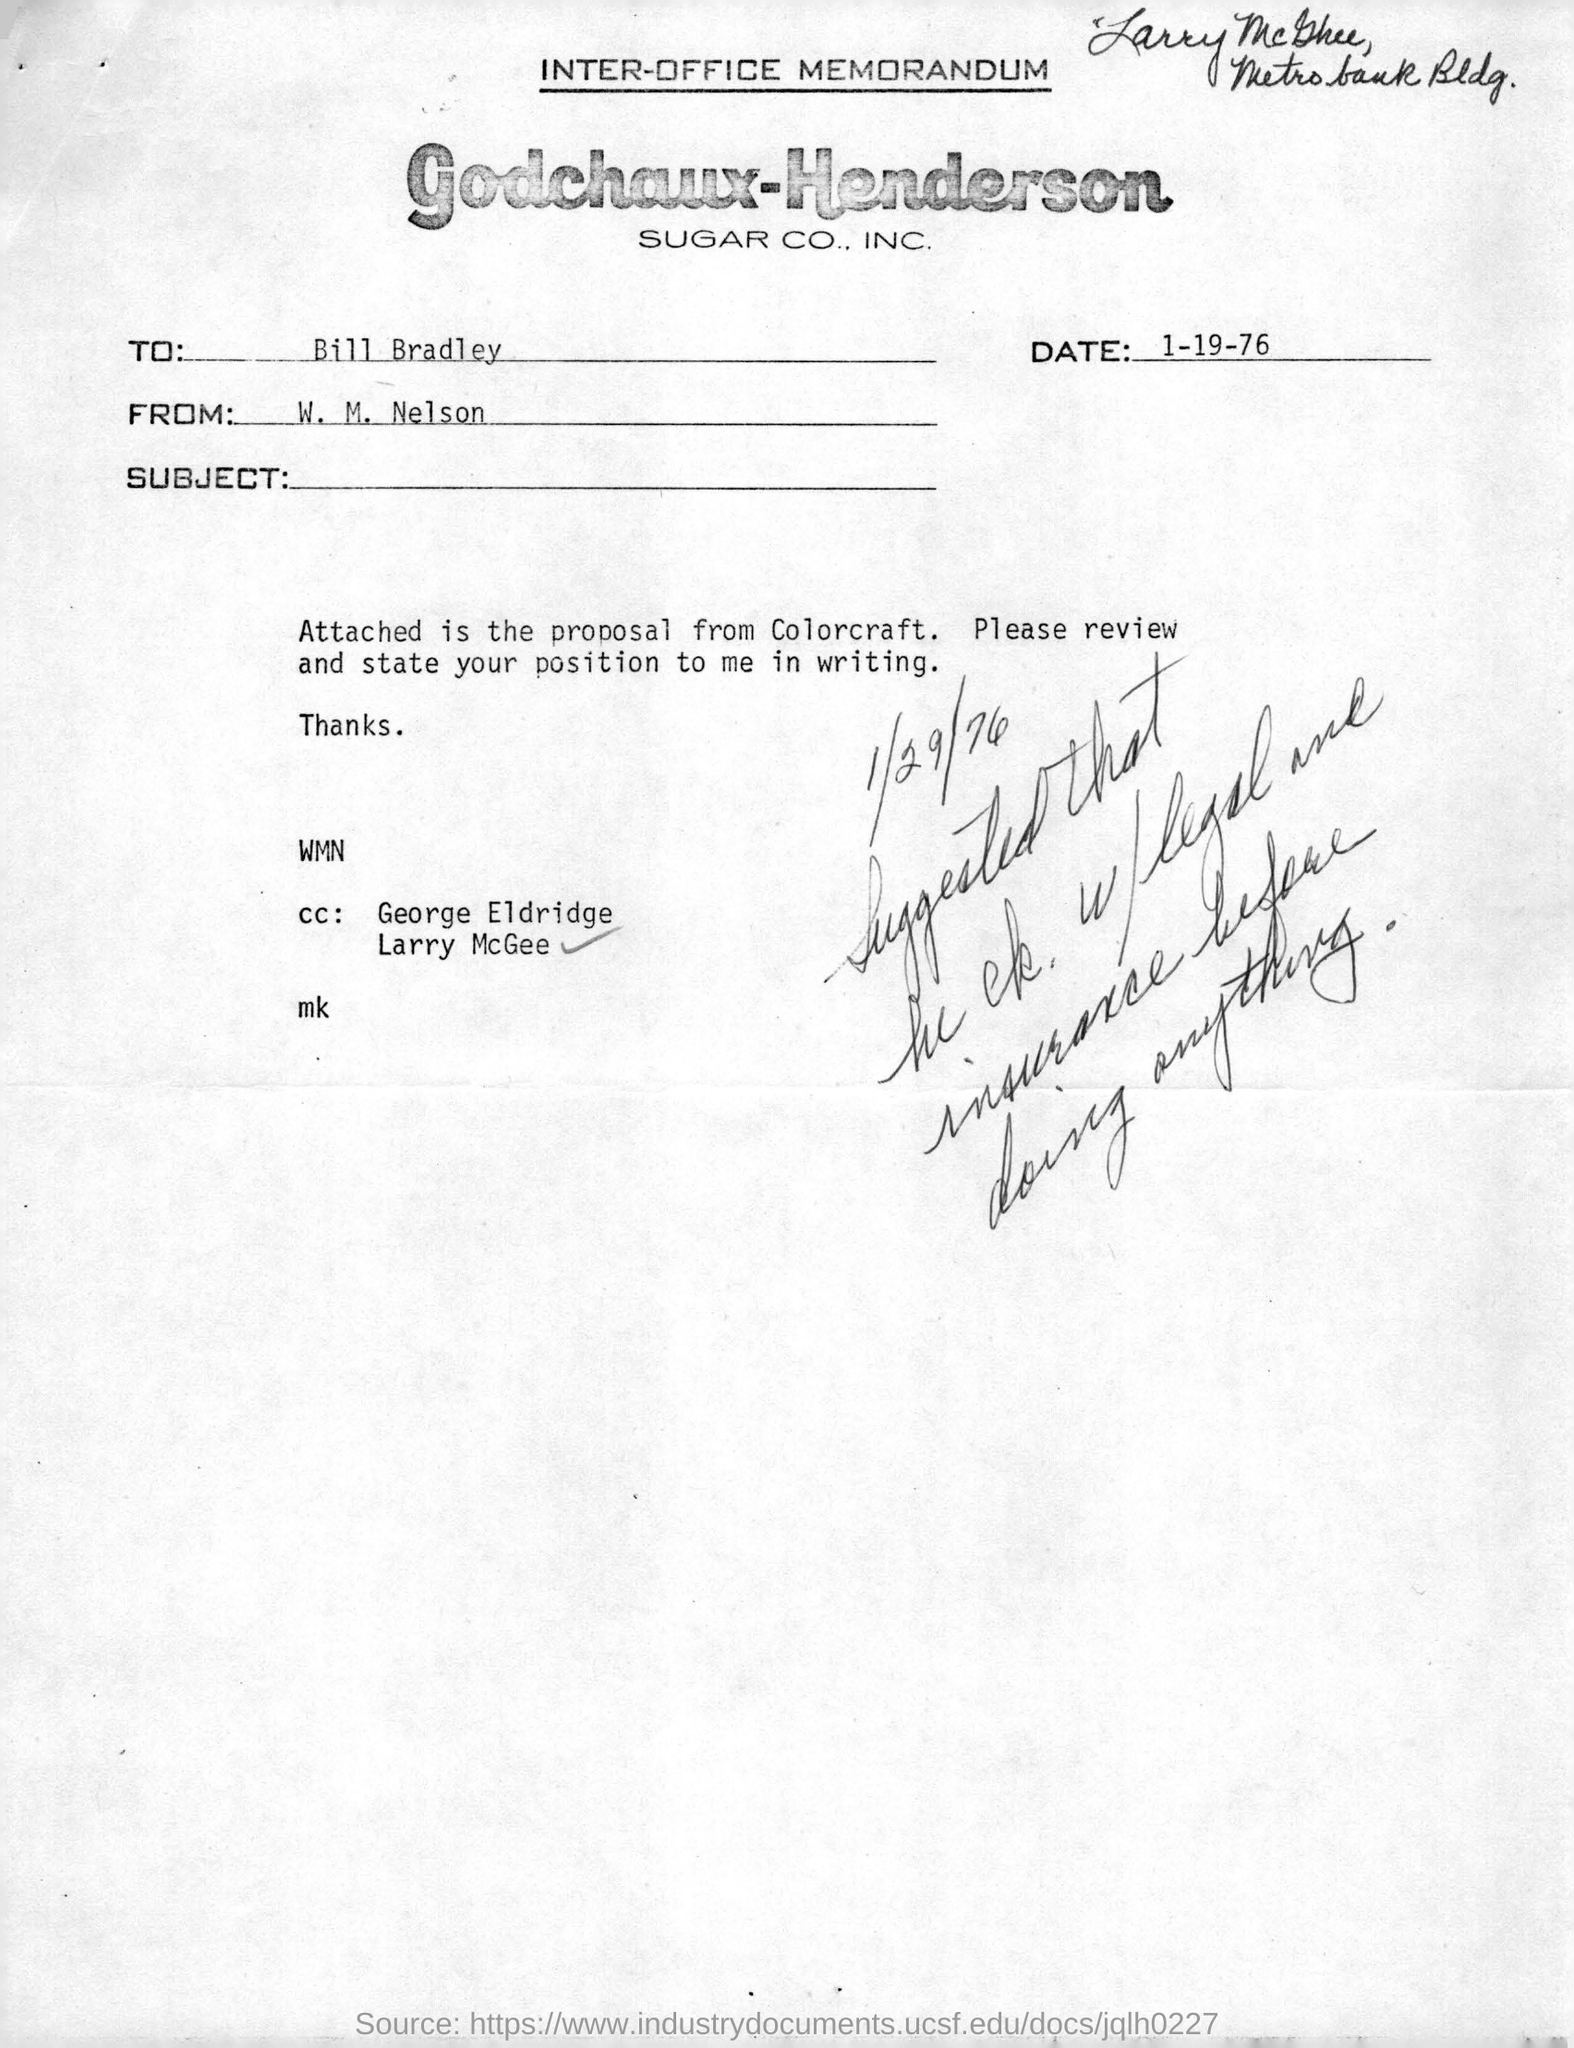Indicate a few pertinent items in this graphic. The memorandum given here belongs to Godchaux-Henderson SUGAR CO., INC. The memorandum is addressed to Bill Bradley. The sender of this memorandum is W. M. Nelson. This is an inter-office memorandum, a type of communication that is used for official, internal communications within an organization. The date mentioned in the memorandum is January 19, 1976. 